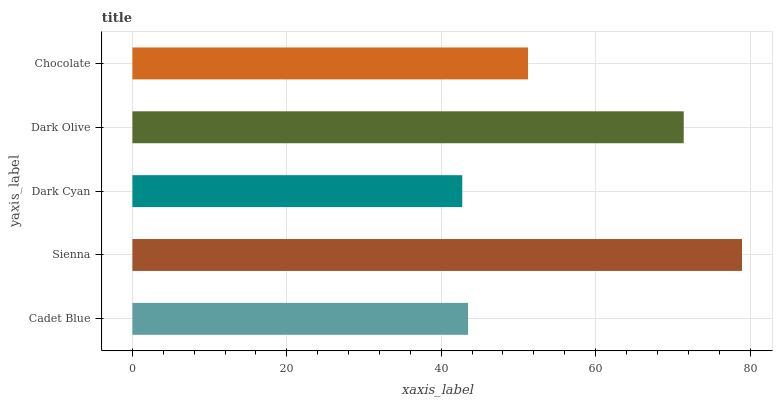Is Dark Cyan the minimum?
Answer yes or no. Yes. Is Sienna the maximum?
Answer yes or no. Yes. Is Sienna the minimum?
Answer yes or no. No. Is Dark Cyan the maximum?
Answer yes or no. No. Is Sienna greater than Dark Cyan?
Answer yes or no. Yes. Is Dark Cyan less than Sienna?
Answer yes or no. Yes. Is Dark Cyan greater than Sienna?
Answer yes or no. No. Is Sienna less than Dark Cyan?
Answer yes or no. No. Is Chocolate the high median?
Answer yes or no. Yes. Is Chocolate the low median?
Answer yes or no. Yes. Is Sienna the high median?
Answer yes or no. No. Is Cadet Blue the low median?
Answer yes or no. No. 